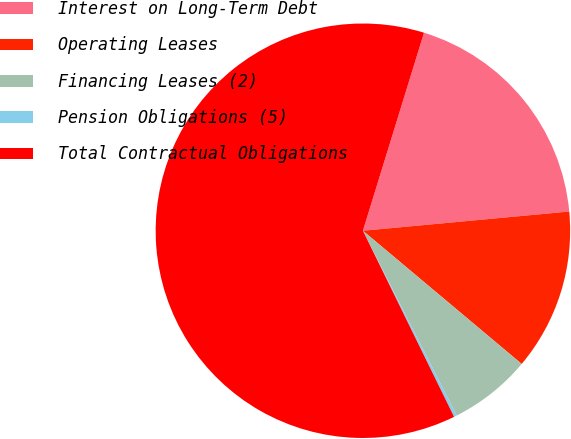<chart> <loc_0><loc_0><loc_500><loc_500><pie_chart><fcel>Interest on Long-Term Debt<fcel>Operating Leases<fcel>Financing Leases (2)<fcel>Pension Obligations (5)<fcel>Total Contractual Obligations<nl><fcel>18.76%<fcel>12.59%<fcel>6.41%<fcel>0.23%<fcel>62.02%<nl></chart> 